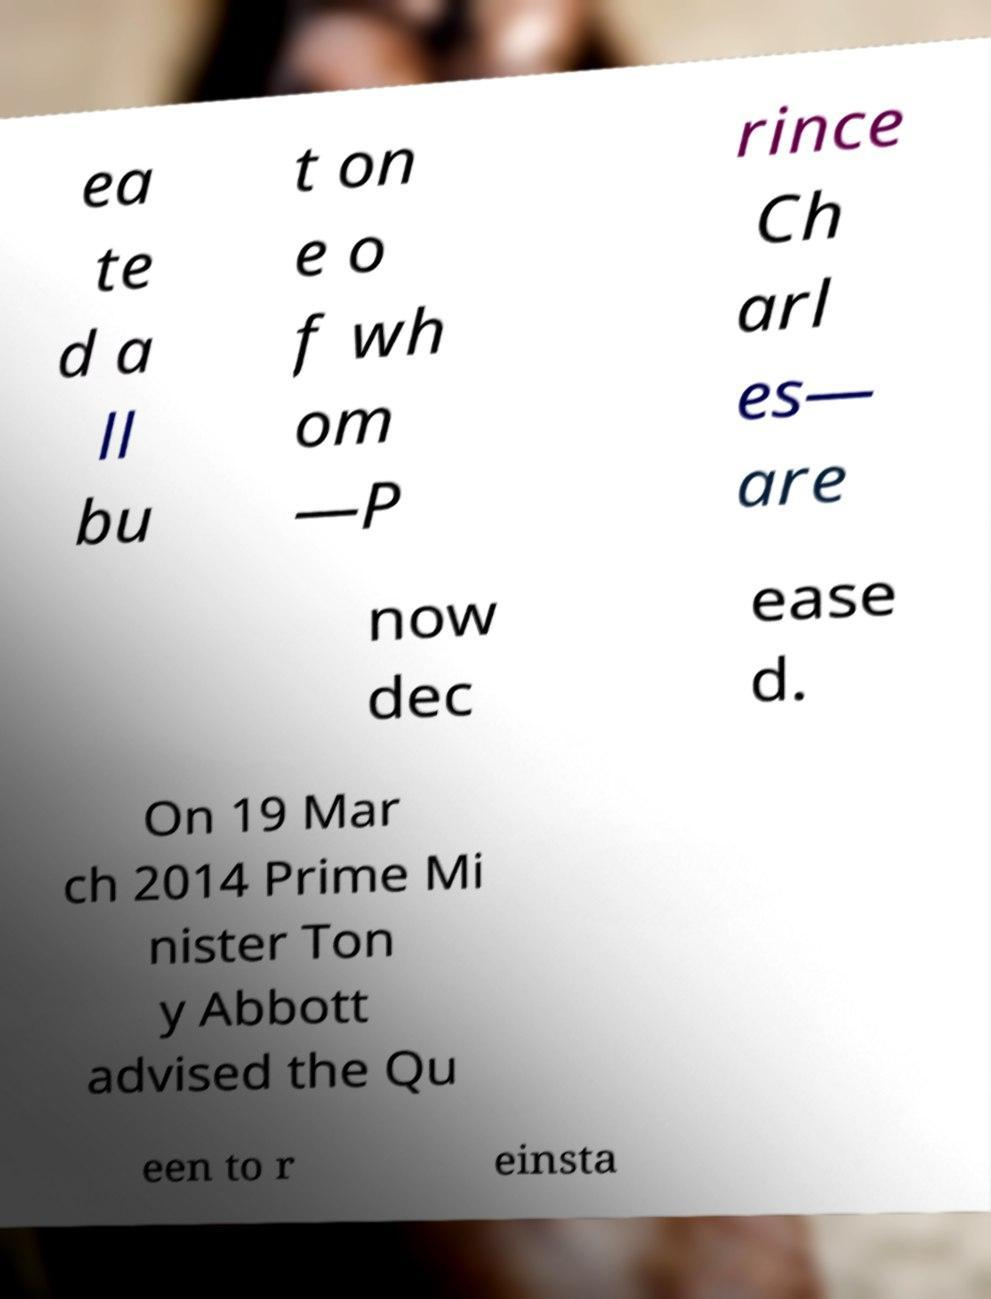Please read and relay the text visible in this image. What does it say? ea te d a ll bu t on e o f wh om —P rince Ch arl es— are now dec ease d. On 19 Mar ch 2014 Prime Mi nister Ton y Abbott advised the Qu een to r einsta 